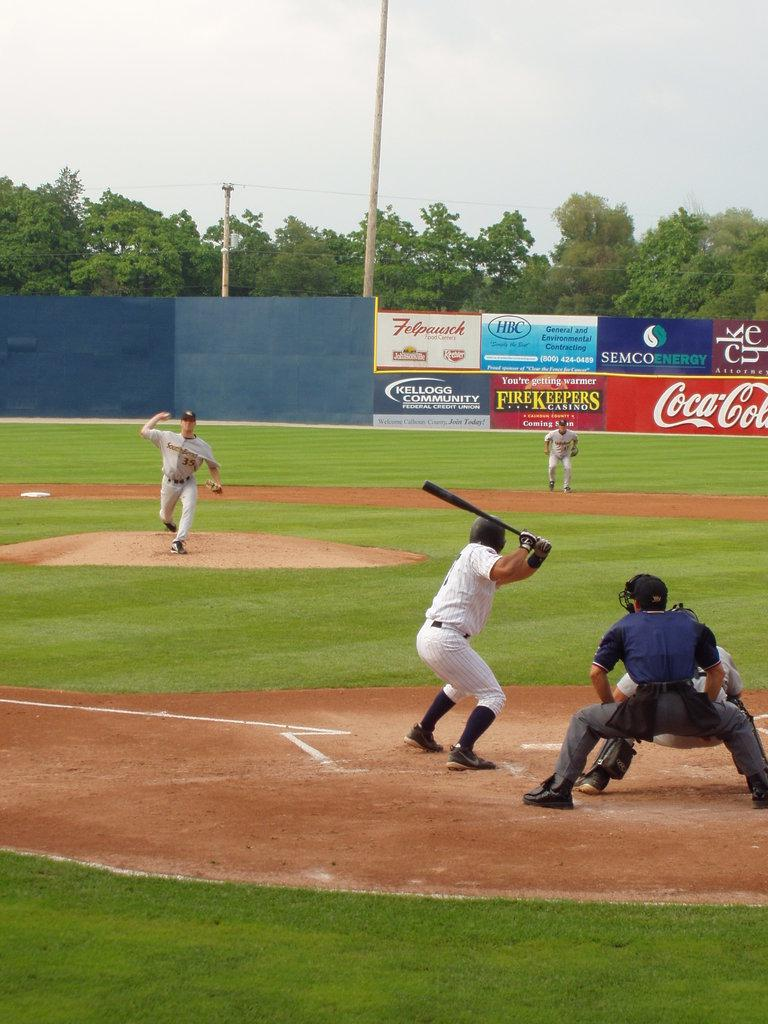<image>
Describe the image concisely. Playing baseball on a field with a Kellogg Community sign in the outfield. 